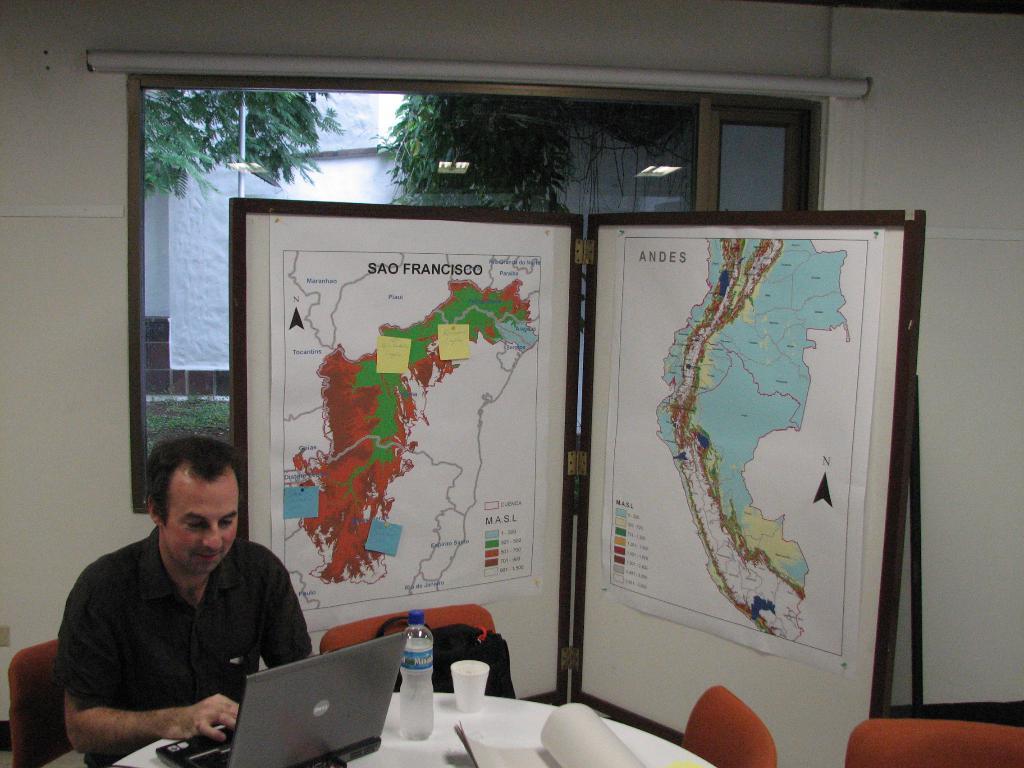In one or two sentences, can you explain what this image depicts? In this picture I can see a person sitting on the chair and using laptop, which is placed on the table and also I can see some things placed on the table, behind there is a boards with some maps and also window to the wall. 